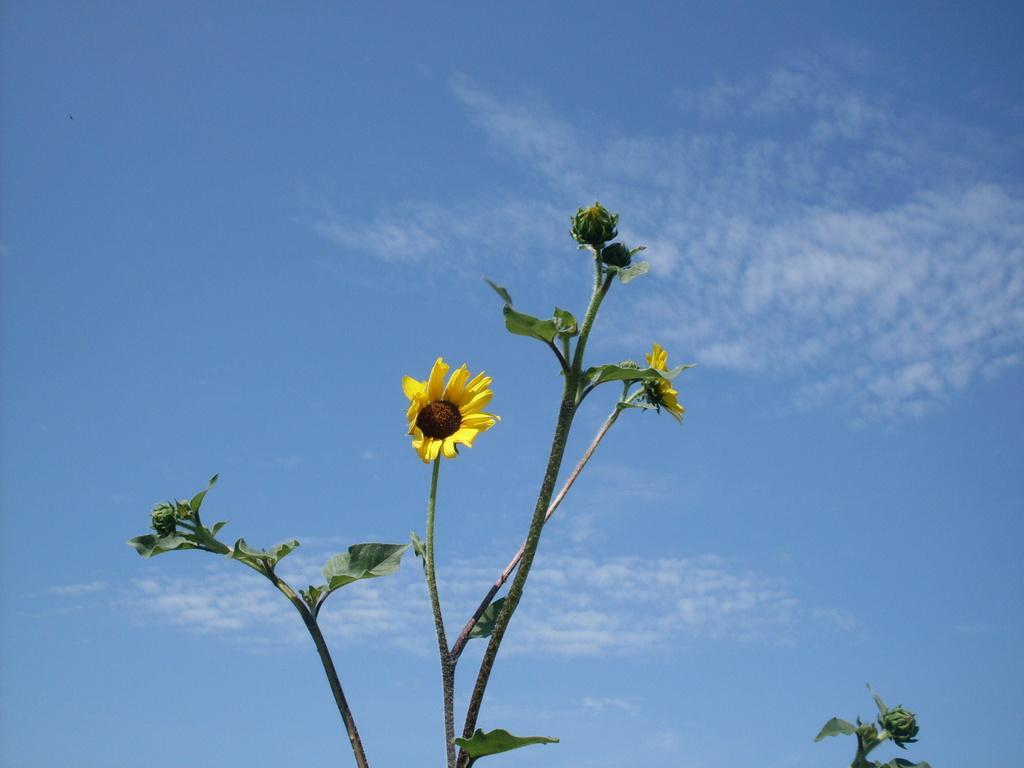Please provide a concise description of this image. In the center of the image, we can see plants with flowers and in the background, there are clouds in the sky. 